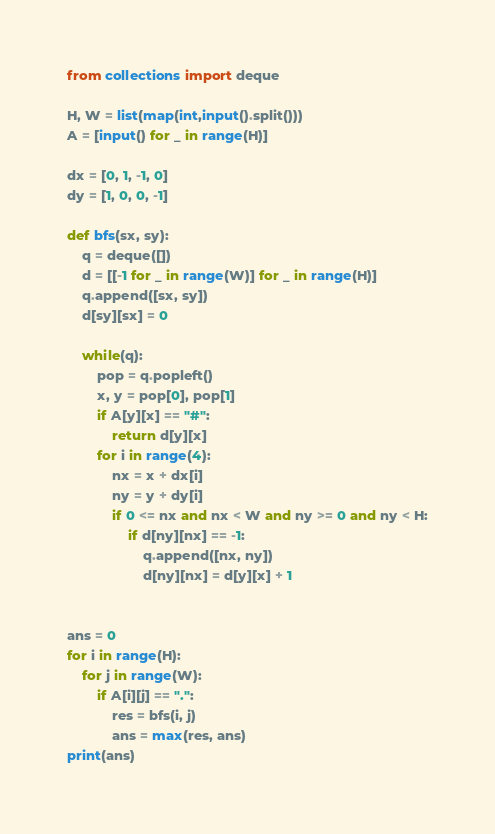Convert code to text. <code><loc_0><loc_0><loc_500><loc_500><_Python_>from collections import deque

H, W = list(map(int,input().split()))
A = [input() for _ in range(H)]

dx = [0, 1, -1, 0]
dy = [1, 0, 0, -1]

def bfs(sx, sy):
    q = deque([])
    d = [[-1 for _ in range(W)] for _ in range(H)]
    q.append([sx, sy])
    d[sy][sx] = 0
    
    while(q):
        pop = q.popleft()
        x, y = pop[0], pop[1]
        if A[y][x] == "#":
            return d[y][x]
        for i in range(4):
            nx = x + dx[i]
            ny = y + dy[i]
            if 0 <= nx and nx < W and ny >= 0 and ny < H:
                if d[ny][nx] == -1:
                    q.append([nx, ny])
                    d[ny][nx] = d[y][x] + 1

                 
ans = 0
for i in range(H):
    for j in range(W):
        if A[i][j] == ".":
            res = bfs(i, j)
            ans = max(res, ans)
print(ans)</code> 